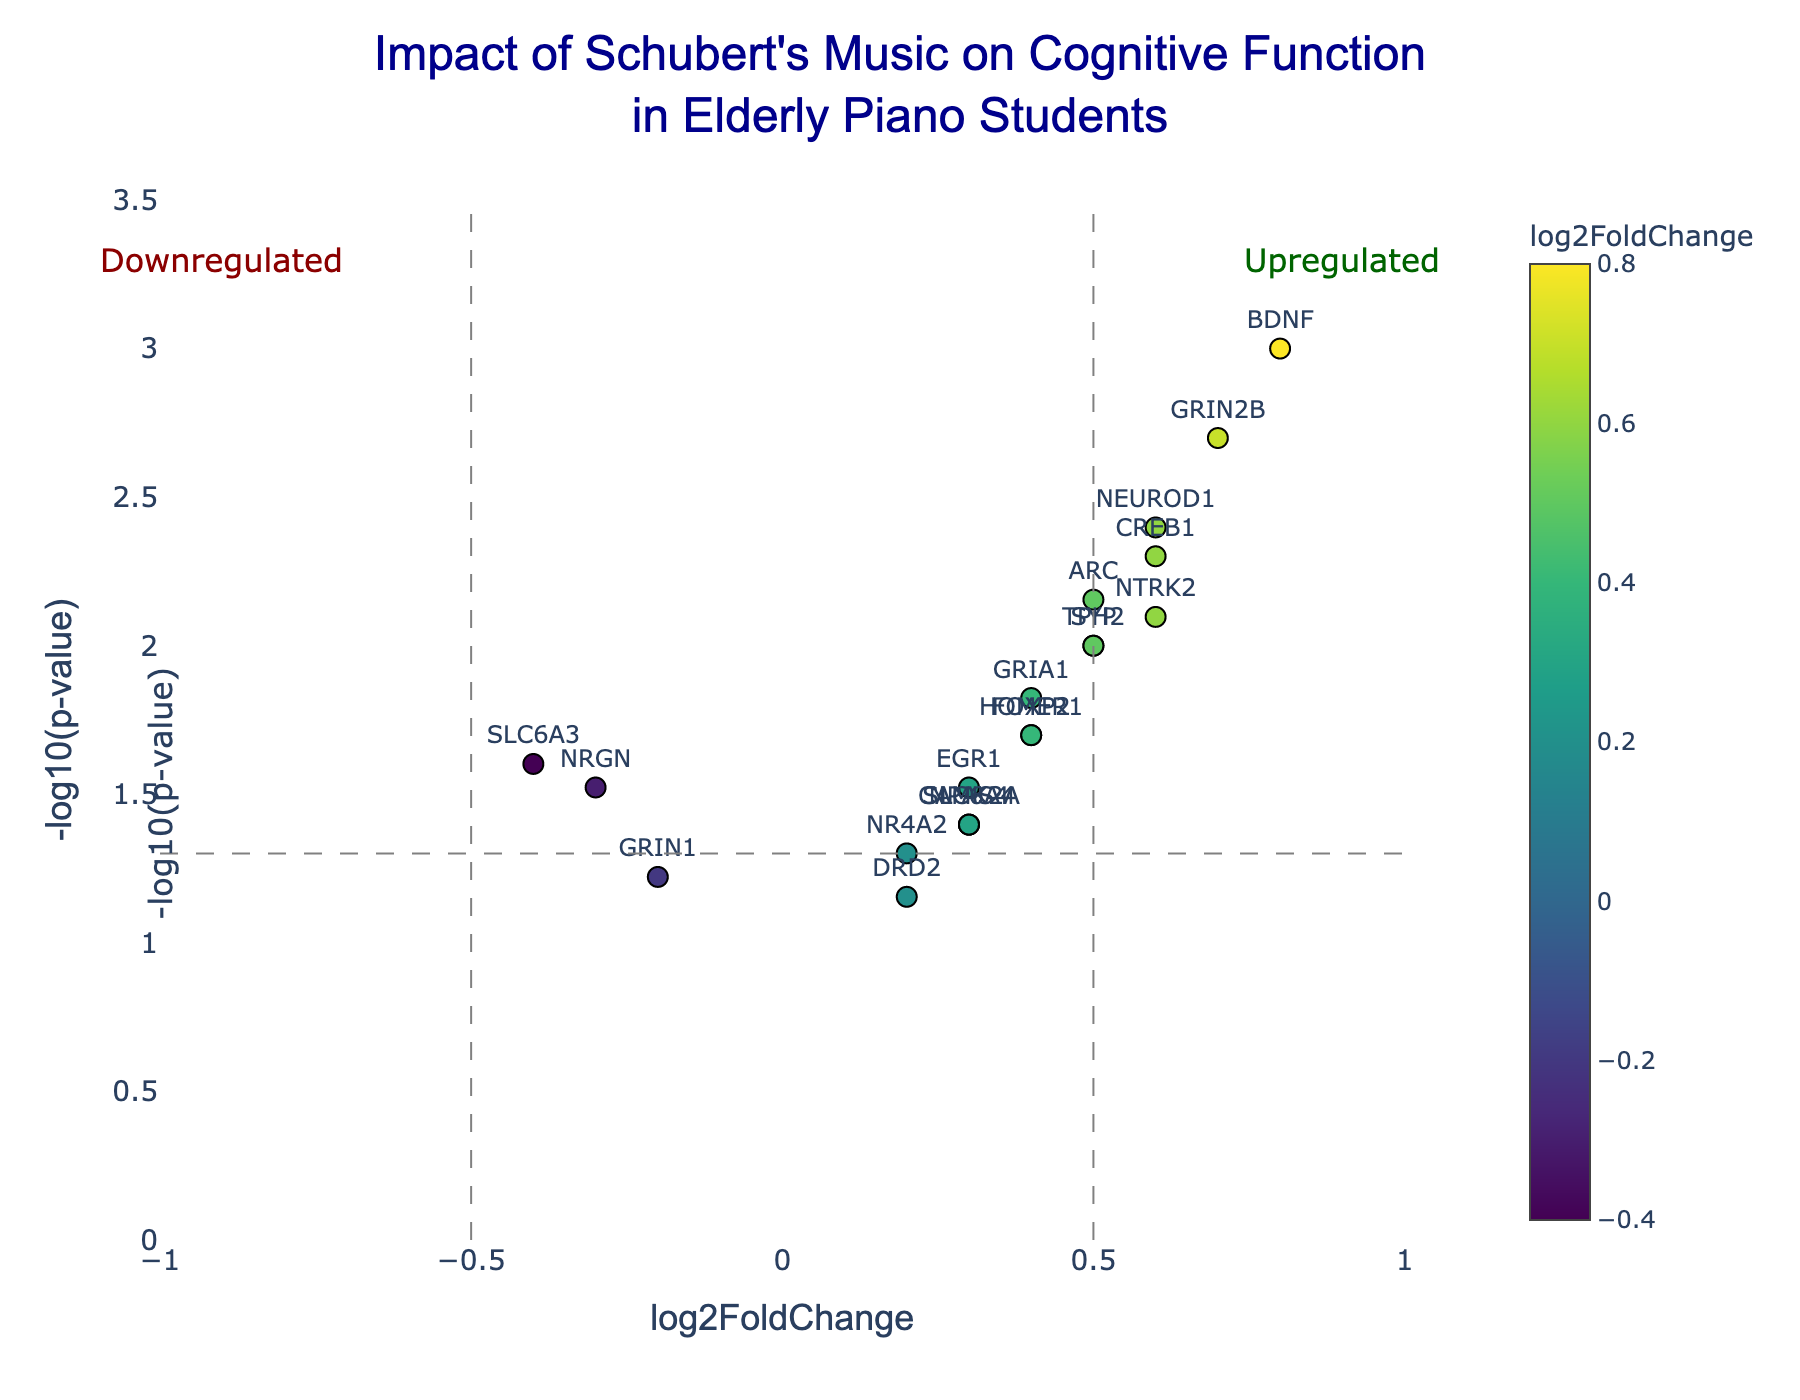What's the title of the figure? The title is placed at the top center of the figure and reads "Impact of Schubert's Music on Cognitive Function in Elderly Piano Students".
Answer: Impact of Schubert's Music on Cognitive Function in Elderly Piano Students What do the x-axis and y-axis represent? The x-axis represents the log2FoldChange of gene expression, while the y-axis represents the -log10(p-value). This is usually indicated on the axis' labels.
Answer: log2FoldChange (x-axis) and -log10(p-value) (y-axis) What color indicates a higher log2FoldChange? The markers are colored using the 'Viridis' colorscale, where colors towards the yellow-green spectrum typically represent higher values. You can also see the color bar to the right of the plot.
Answer: Yellow-green Which gene has the highest -log10(p-value) and what does it imply? The gene BDNF has the highest -log10(p-value) of around 3, indicating it has the most statistically significant change in expression due to Schubert's music.
Answer: BDNF Which genes are downregulated but not statistically significant? Genes with log2FoldChange values less than 0 and -log10(p-value) values less than the threshold line (i.e., 1.301) are downregulated but not significant. GRIN1 and DRD2 meet these criteria.
Answer: GRIN1 and DRD2 How many genes have a log2FoldChange greater than 0.5 and are statistically significant? Statistically significant genes have -log10(p-value) values above the threshold line (i.e., 1.301) and log2FoldChange greater than 0.5. By looking at the plot, BDNF, GRIN2B, and NEUROD1 meet these criteria.
Answer: 3 Which gene has the largest positive log2FoldChange? The gene BDNF is positioned farthest to the right on the x-axis, showing the largest positive log2FoldChange of 0.8.
Answer: BDNF What does the horizontal dashed line represent? The horizontal dashed line represents the significance threshold, which is usually set at -log10(p-value) of 1.301 (equivalent to a p-value of 0.05).
Answer: Significance threshold (p-value = 0.05) Compare SYP and NRGN. Which one has a higher log2FoldChange? SYP has a log2FoldChange of 0.5, whereas NRGN has a log2FoldChange of -0.3. Comparing these values, SYP has a higher log2FoldChange.
Answer: SYP Which gene with a positive log2FoldChange is the least statistically significant? Among the genes with positive log2FoldChange values, DRD2 has a -log10(p-value) close to 1.15, making it the least statistically significant.
Answer: DRD2 